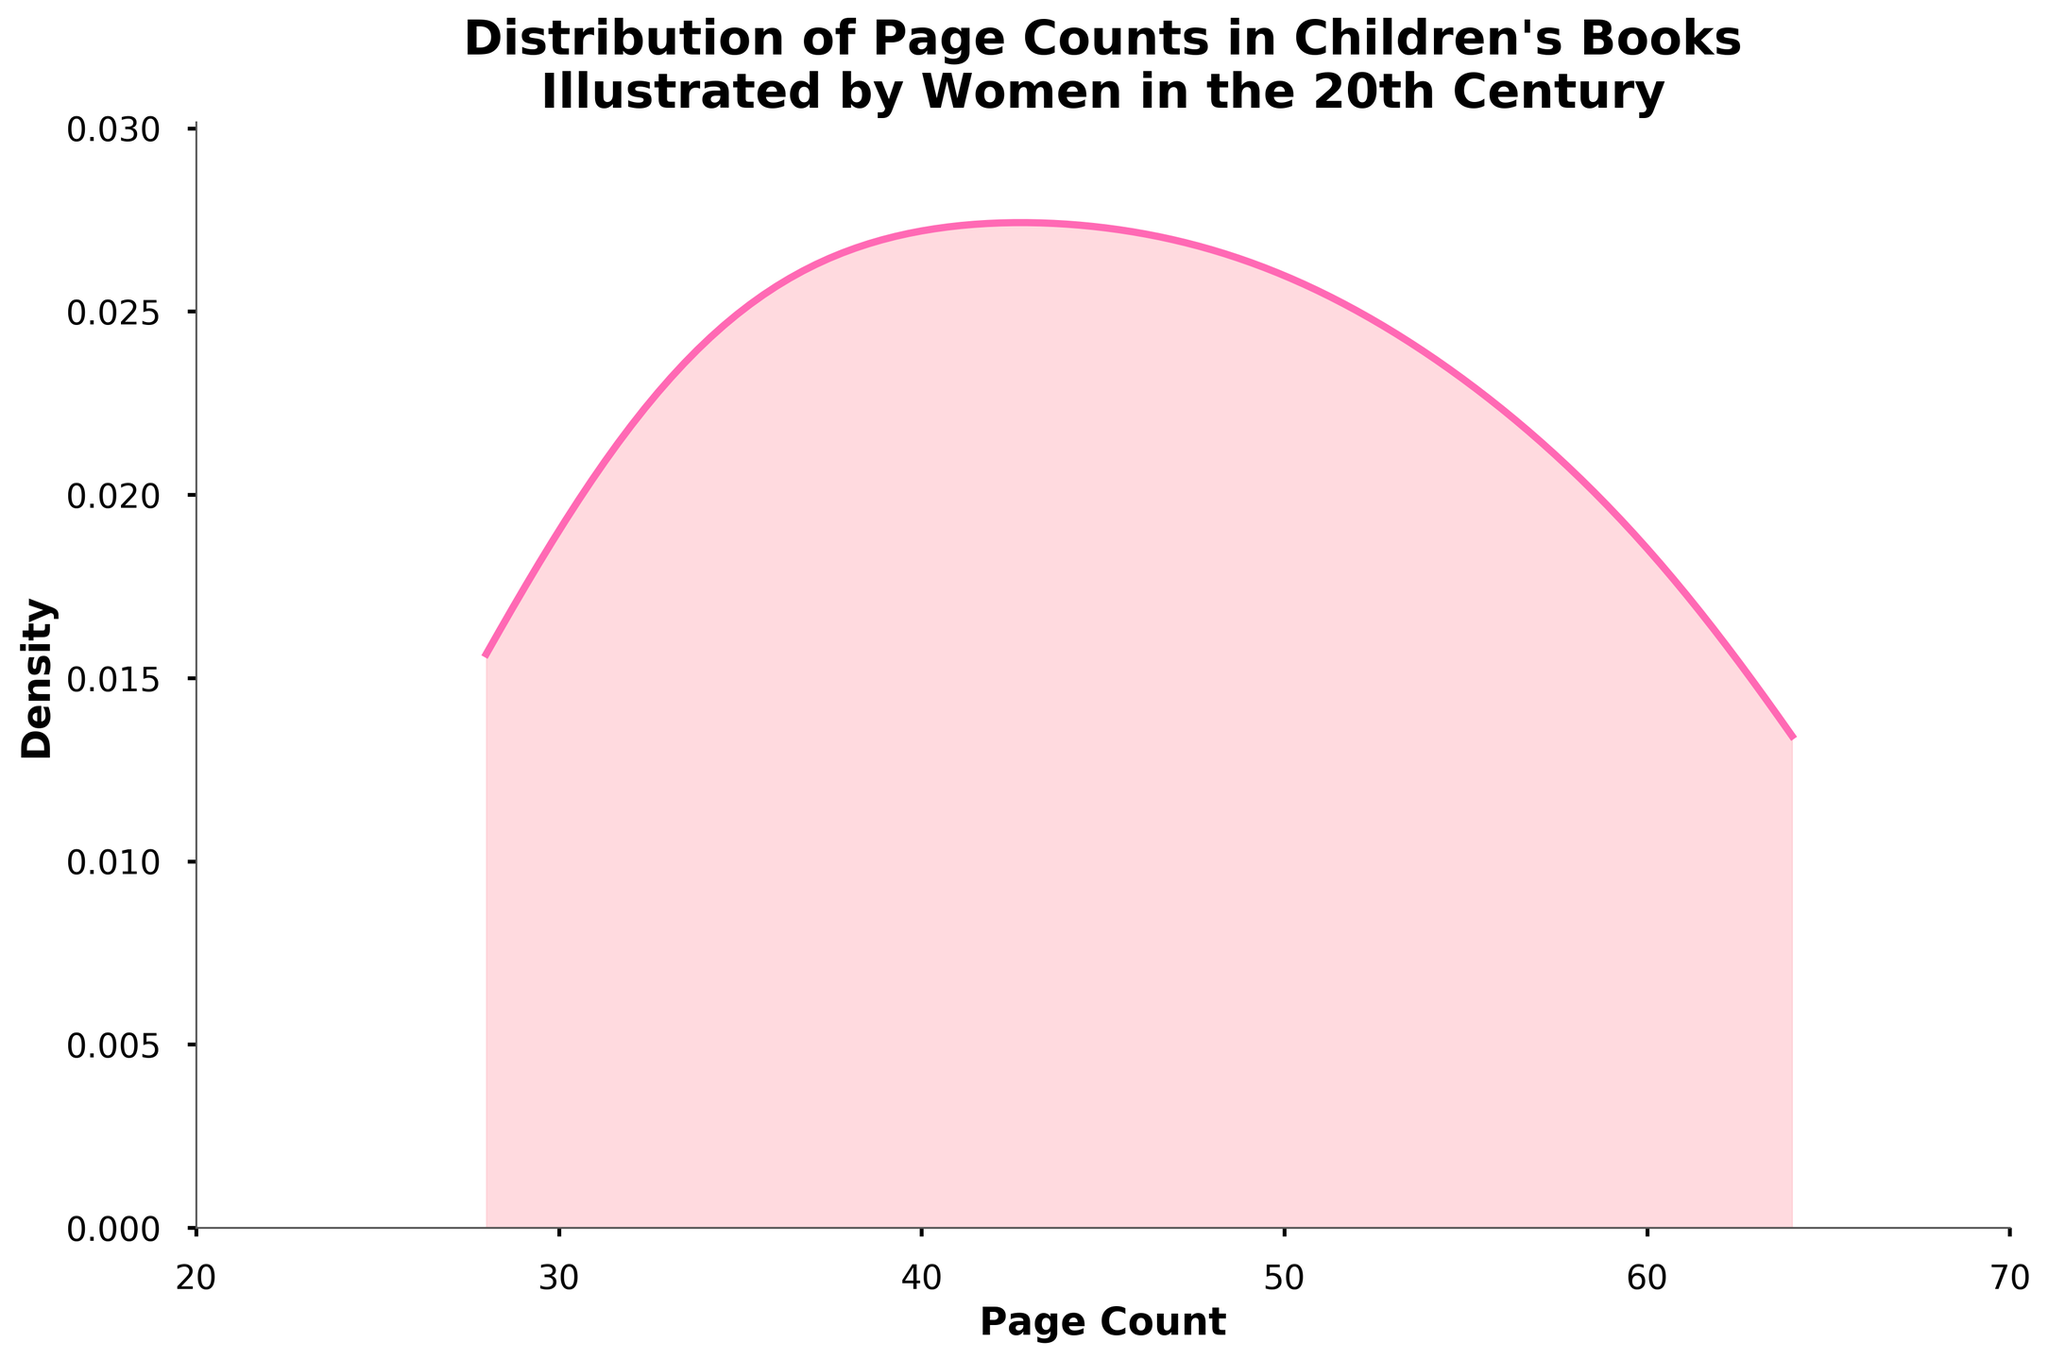what is the title of the plot? The title of the plot is usually located at the top and provides a summary of what the plot is about. In this plot, it reads, "Distribution of Page Counts in Children's Books Illustrated by Women in the 20th Century".
Answer: Distribution of Page Counts in Children's Books Illustrated by Women in the 20th Century What is the range of the Page Count axis? The Page Count axis is located on the horizontal or x-axis. The range is specified at both ends of the axis. In this plot, it starts from 20 and goes up to 70.
Answer: 20 to 70 What is the peak density value of the distribution? By examining the height of the density curve, we can see the peak (or the highest point). In this particular plot, the peak density appears between page counts 30 to 40.
Answer: Between 30 to 40 How would you describe the overall shape of the density plot? The shape of the density plot reveals the distribution pattern of page counts. In this case, it appears to be unimodal with a single peak between 30-40 pages, and it decreases on either side of this peak.
Answer: Unimodal with a peak between 30-40 pages Is the distribution symmetrical? A symmetrical distribution would have equal spread on both sides of the peak. This plot shows that the distribution is more spread out on the right side (higher page counts) than on the left side.
Answer: No, it is not symmetrical What is the approximate density value at a page count of 60? By referring to the density curve at the page count of 60 on the x-axis, the approximate density value can be determined. It appears to be around 0.004.
Answer: Around 0.004 Compare the density at page counts 30 and 50. Which is higher? We can compare the density values at these two page counts by looking at the heights of the density curve at these points. The density at page count 30 is higher than that at page count 50.
Answer: Page count 30 What can be inferred about the frequency of books with around 32 pages compared to those with around 62 pages? The density at 32 pages is much higher than at 62 pages, implying that children's books illustrated by women in the 20th century were more frequently around 32 pages compared to 62 pages.
Answer: More frequent at 32 pages What does the area under the density curve represent in this context? In this density plot, the area under the curve represents the probability distribution of page counts in children's books illustrated by women in the 20th century.
Answer: Probability distribution of page counts Is there a significant number of books with page counts greater than 50? By looking at the density values for page counts greater than 50, it can be seen that the density is relatively low, indicating fewer books in this range.
Answer: No, not significant 